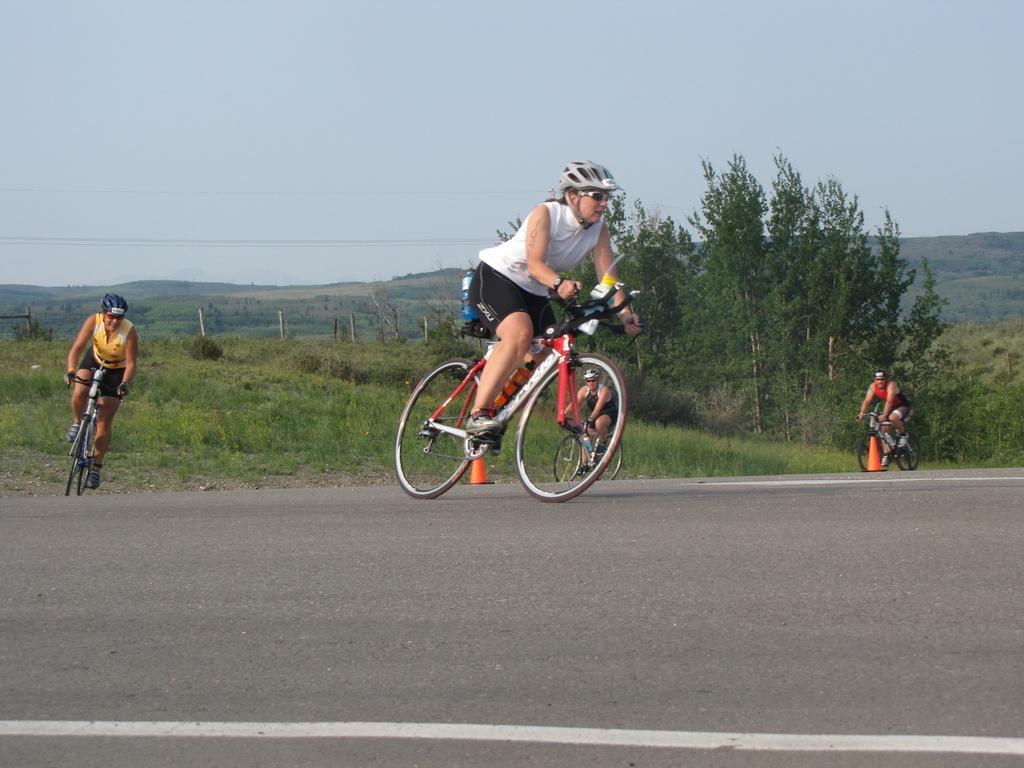Could you give a brief overview of what you see in this image? In this image there are people riding bicycles. In the background there are trees, hills and sky. We can see traffic cones. 